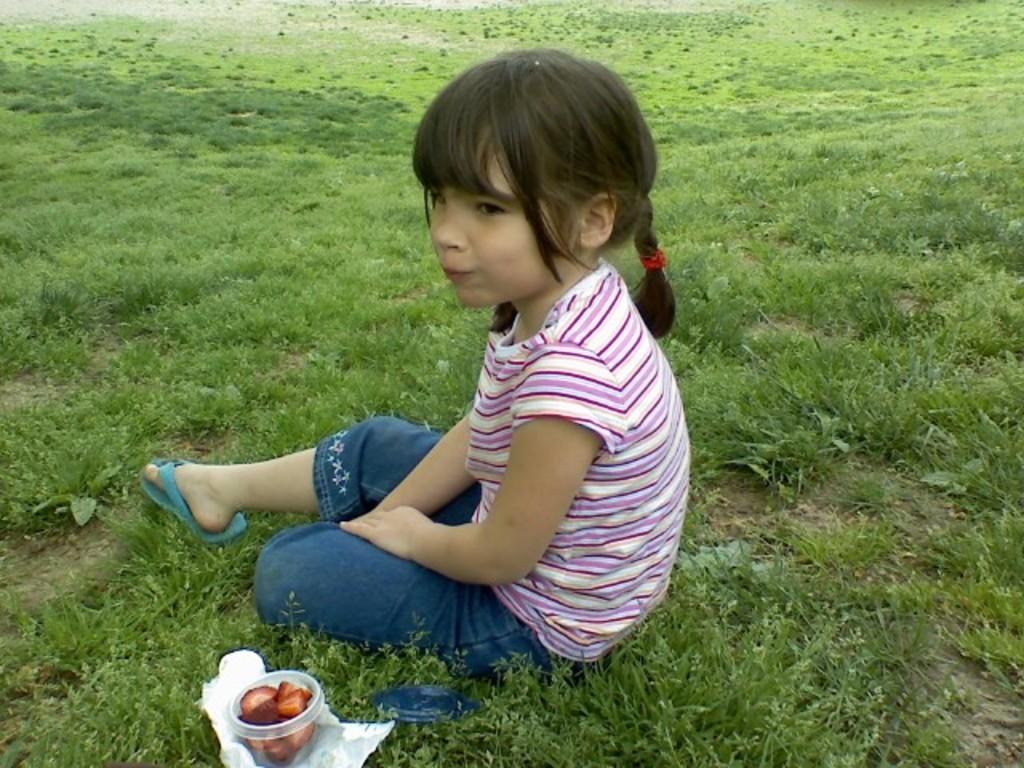How would you summarize this image in a sentence or two? There is a girl sitting on the grass. Here we can see a box, paper, and food. 